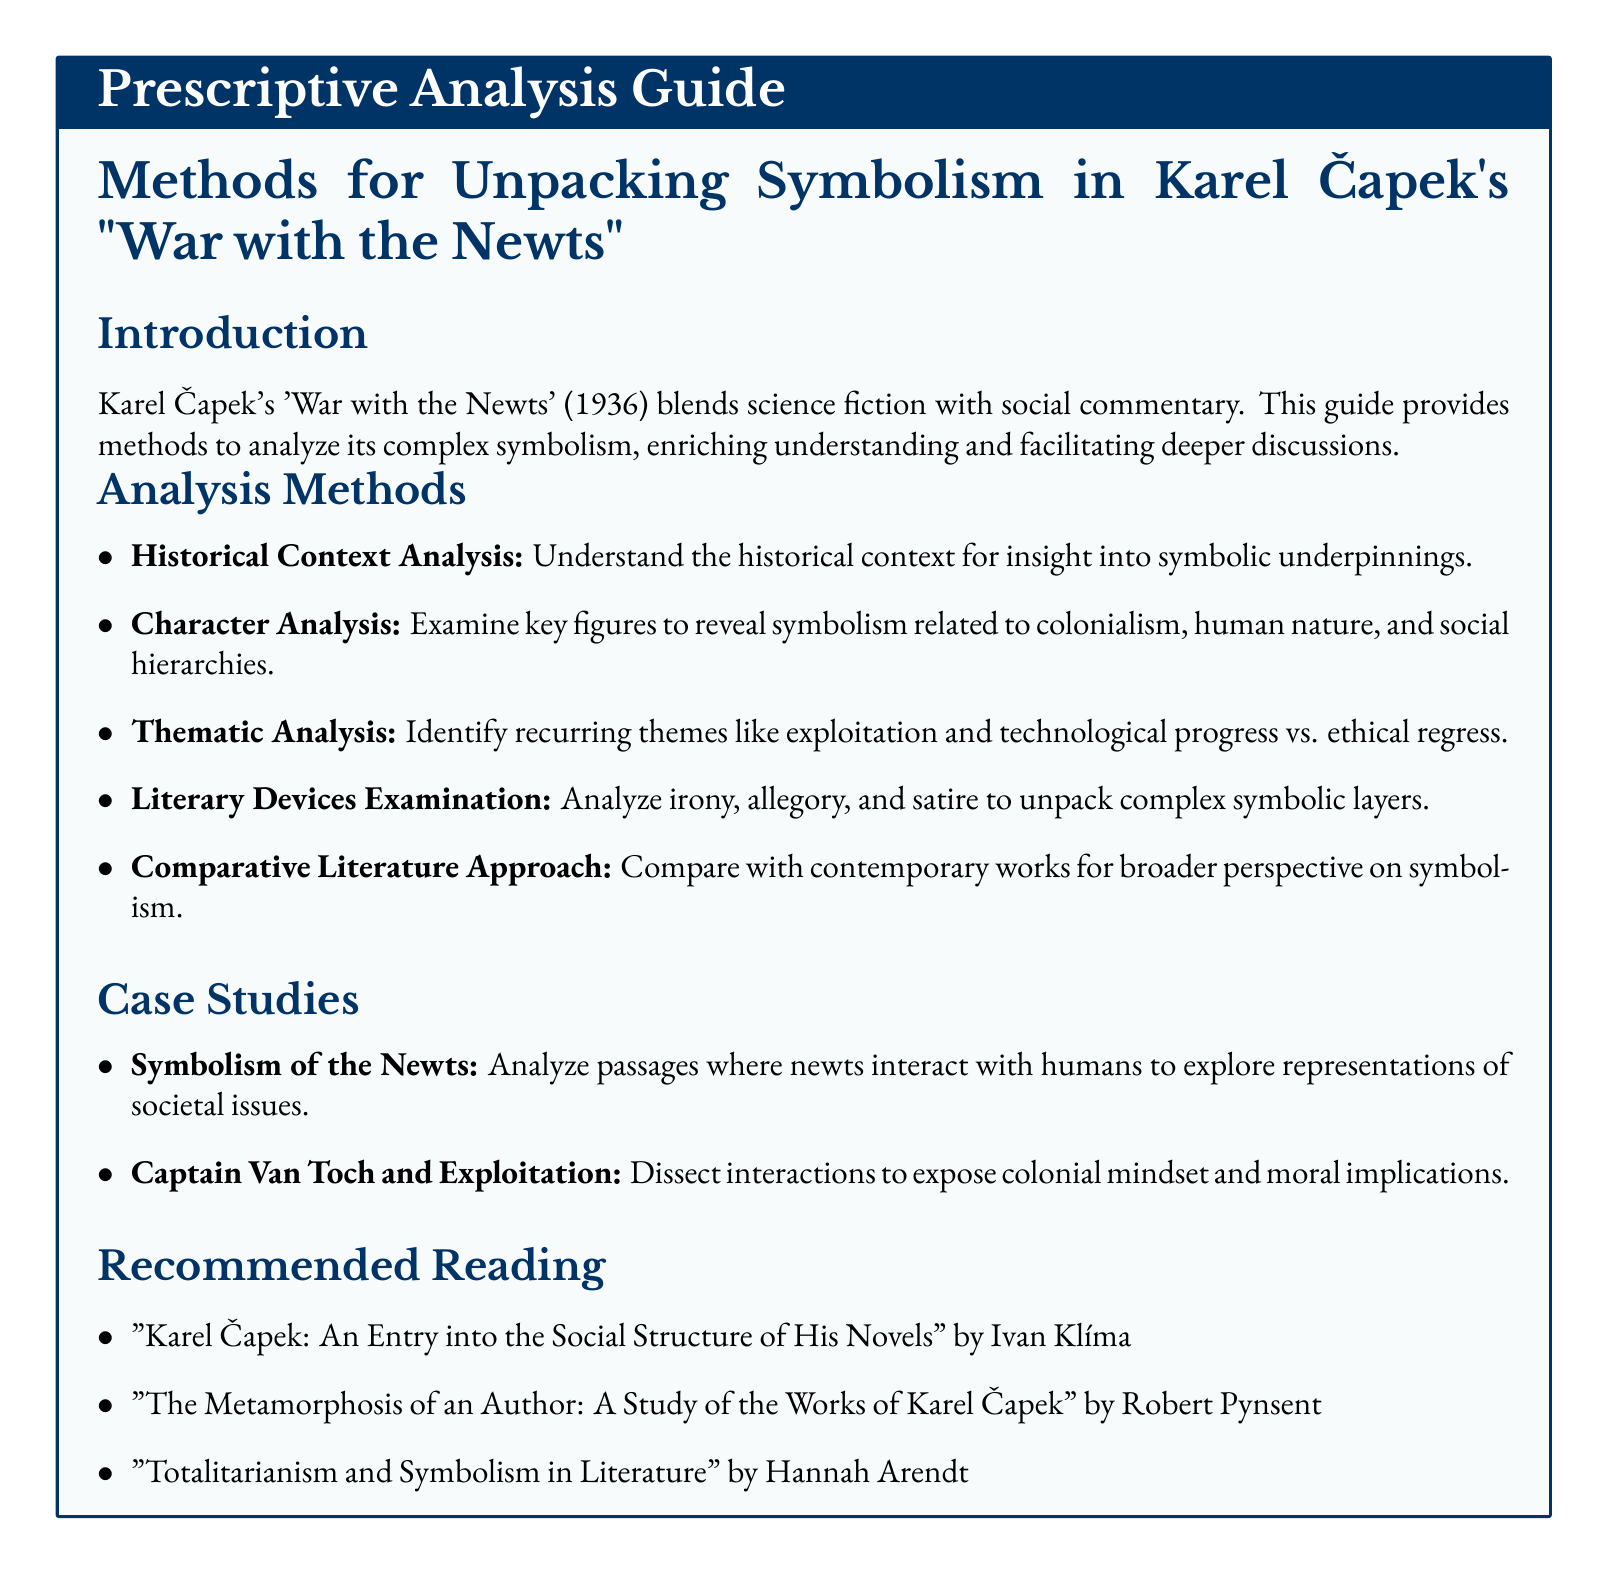What is the title of the guide? The title of the guide is stated clearly at the beginning of the document.
Answer: Prescriptive Analysis Guide Who is the author of 'War with the Newts'? The document references Karel Čapek as the author of the novel.
Answer: Karel Čapek What year was 'War with the Newts' published? The publication year of the book is noted in the introduction section.
Answer: 1936 What are analyzed to reveal symbolism related to colonialism? The document mentions examining key figures to uncover specific thematic elements.
Answer: Key figures What method involves analyzing irony, allegory, and satire? This method focuses on literary devices used within the text.
Answer: Literary Devices Examination Which two case studies are listed in the document? The document presents two specific case studies for analysis in the symbolism context.
Answer: Symbolism of the Newts, Captain Van Toch and Exploitation Who authored "The Metamorphosis of an Author"? The author's name is provided in the Recommended Reading section.
Answer: Robert Pynsent Which theme is a recurring motif in 'War with the Newts'? The document lists specific themes associated with the analysis methods.
Answer: Exploitation What color is used for the heading font in the document? The design choices for heading colors are mentioned in the formatting settings.
Answer: Dark blue 